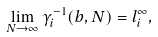<formula> <loc_0><loc_0><loc_500><loc_500>\lim _ { N \rightarrow \infty } \gamma _ { i } ^ { - 1 } ( b , N ) = l _ { i } ^ { \infty } , \,</formula> 